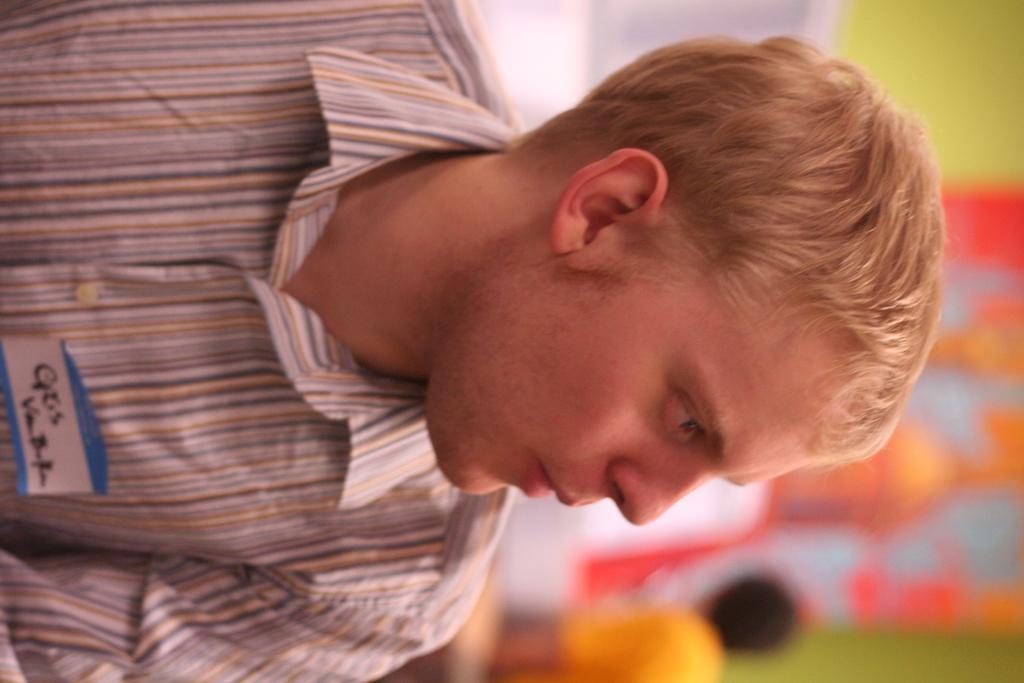Can you describe this image briefly? In this image we can see one person, at the bottom we can see some written text on the paper, we can see the background is blurred. 